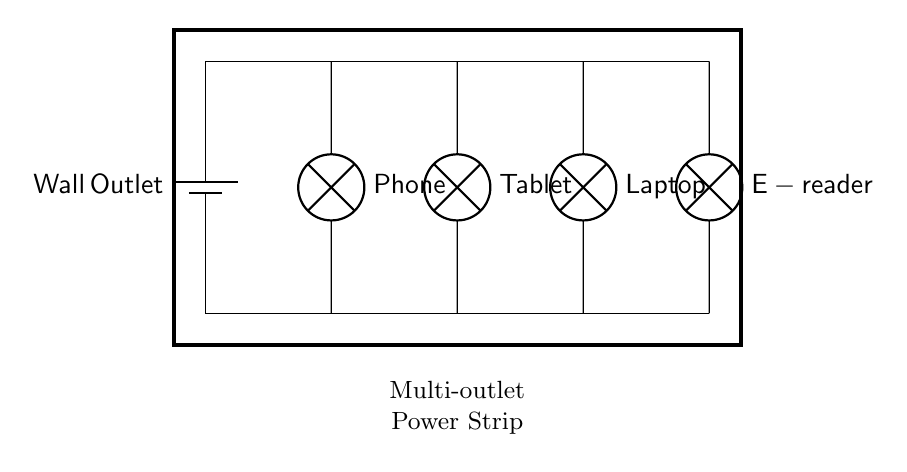What is the source of power in this circuit? The circuit receives power from the wall outlet, which is represented by the battery symbol in the diagram. This indicates that the circuit is powered by a standard household electrical supply.
Answer: Wall Outlet How many devices are connected in this circuit? The diagram shows four lamps, each representing a different device (phone, tablet, laptop, and e-reader), indicating a total of four connected devices.
Answer: Four What type of circuit is represented in the diagram? The circuit diagram displays a parallel circuit since there are multiple branches emanating from a common power source, allowing each device to operate independently.
Answer: Parallel What will happen if one device fails? In a parallel circuit, if one device (lamp) fails or is disconnected, the remaining devices will continue to function normally because each has its own path to the power source.
Answer: Remains functional What is the purpose of the multi-outlet power strip in this circuit? The power strip allows multiple devices to connect to a single wall outlet, providing convenience and enabling multiple electronic devices to be powered at the same time.
Answer: Convenience What kind of connection exists between the devices? Each device is connected in parallel, allowing them to share the same voltage from the wall outlet without affecting one another's operation.
Answer: Parallel connection 